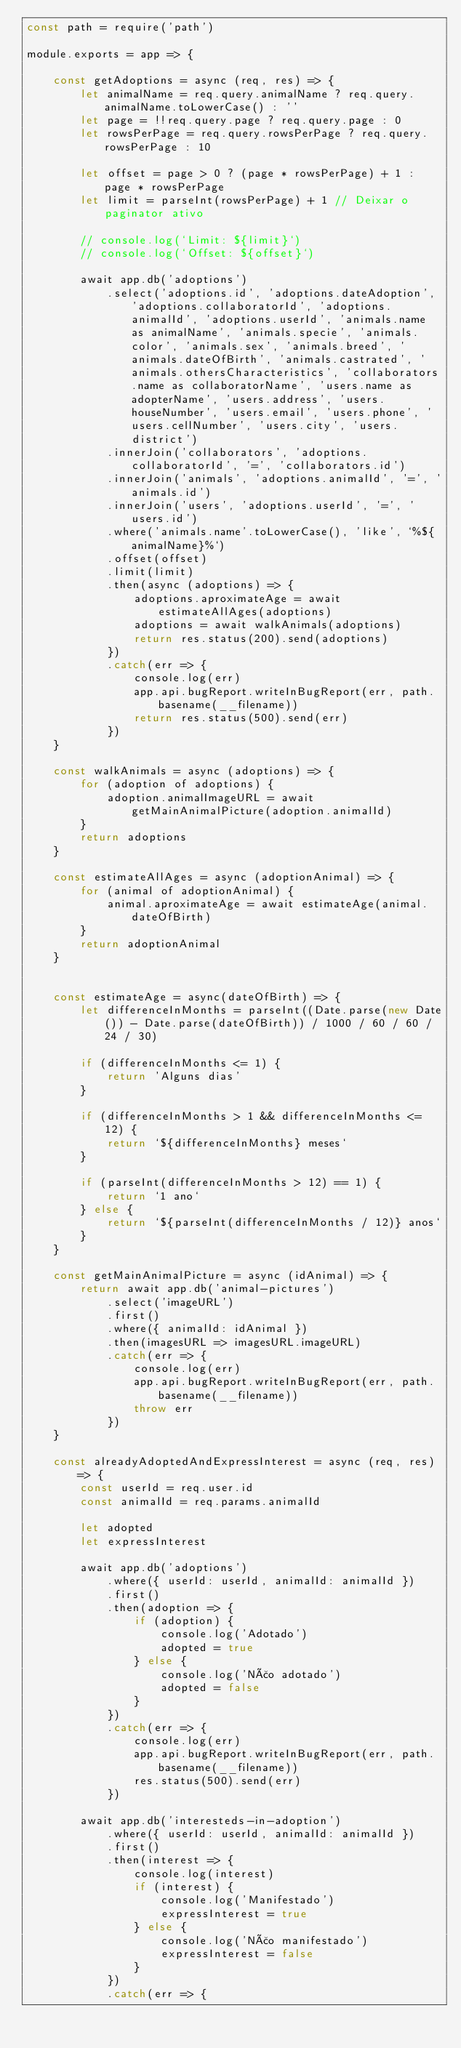<code> <loc_0><loc_0><loc_500><loc_500><_JavaScript_>const path = require('path')

module.exports = app => {

    const getAdoptions = async (req, res) => {
        let animalName = req.query.animalName ? req.query.animalName.toLowerCase() : ''
        let page = !!req.query.page ? req.query.page : 0
        let rowsPerPage = req.query.rowsPerPage ? req.query.rowsPerPage : 10

        let offset = page > 0 ? (page * rowsPerPage) + 1 : page * rowsPerPage
        let limit = parseInt(rowsPerPage) + 1 // Deixar o paginator ativo

        // console.log(`Limit: ${limit}`)
        // console.log(`Offset: ${offset}`)

        await app.db('adoptions')
            .select('adoptions.id', 'adoptions.dateAdoption', 'adoptions.collaboratorId', 'adoptions.animalId', 'adoptions.userId', 'animals.name as animalName', 'animals.specie', 'animals.color', 'animals.sex', 'animals.breed', 'animals.dateOfBirth', 'animals.castrated', 'animals.othersCharacteristics', 'collaborators.name as collaboratorName', 'users.name as adopterName', 'users.address', 'users.houseNumber', 'users.email', 'users.phone', 'users.cellNumber', 'users.city', 'users.district')
            .innerJoin('collaborators', 'adoptions.collaboratorId', '=', 'collaborators.id')
            .innerJoin('animals', 'adoptions.animalId', '=', 'animals.id')
            .innerJoin('users', 'adoptions.userId', '=', 'users.id')
            .where('animals.name'.toLowerCase(), 'like', `%${animalName}%`)
            .offset(offset)
            .limit(limit)
            .then(async (adoptions) => {
                adoptions.aproximateAge = await estimateAllAges(adoptions)
                adoptions = await walkAnimals(adoptions)
                return res.status(200).send(adoptions)
            })
            .catch(err => {
                console.log(err)
                app.api.bugReport.writeInBugReport(err, path.basename(__filename))
                return res.status(500).send(err)
            })
    }

    const walkAnimals = async (adoptions) => {
        for (adoption of adoptions) {
            adoption.animalImageURL = await getMainAnimalPicture(adoption.animalId)
        }
        return adoptions
    }

    const estimateAllAges = async (adoptionAnimal) => {
        for (animal of adoptionAnimal) {
            animal.aproximateAge = await estimateAge(animal.dateOfBirth)
        }
        return adoptionAnimal
    }


    const estimateAge = async(dateOfBirth) => {
        let differenceInMonths = parseInt((Date.parse(new Date()) - Date.parse(dateOfBirth)) / 1000 / 60 / 60 / 24 / 30)

        if (differenceInMonths <= 1) {
            return 'Alguns dias'
        }

        if (differenceInMonths > 1 && differenceInMonths <= 12) {
            return `${differenceInMonths} meses`
        }

        if (parseInt(differenceInMonths > 12) == 1) {
            return `1 ano`
        } else {
            return `${parseInt(differenceInMonths / 12)} anos`
        }
    }

    const getMainAnimalPicture = async (idAnimal) => {
        return await app.db('animal-pictures')
            .select('imageURL')
            .first()
            .where({ animalId: idAnimal })
            .then(imagesURL => imagesURL.imageURL)
            .catch(err => {
                console.log(err)
                app.api.bugReport.writeInBugReport(err, path.basename(__filename))
                throw err
            })
    }

    const alreadyAdoptedAndExpressInterest = async (req, res) => {
        const userId = req.user.id
        const animalId = req.params.animalId

        let adopted
        let expressInterest

        await app.db('adoptions')
            .where({ userId: userId, animalId: animalId })
            .first()
            .then(adoption => {
                if (adoption) {
                    console.log('Adotado')
                    adopted = true
                } else {
                    console.log('Não adotado')
                    adopted = false
                }
            })
            .catch(err => {
                console.log(err)
                app.api.bugReport.writeInBugReport(err, path.basename(__filename))
                res.status(500).send(err)
            })

        await app.db('interesteds-in-adoption')
            .where({ userId: userId, animalId: animalId })
            .first()
            .then(interest => {
                console.log(interest)
                if (interest) {
                    console.log('Manifestado')
                    expressInterest = true
                } else {
                    console.log('Não manifestado')
                    expressInterest = false
                }
            })
            .catch(err => {</code> 